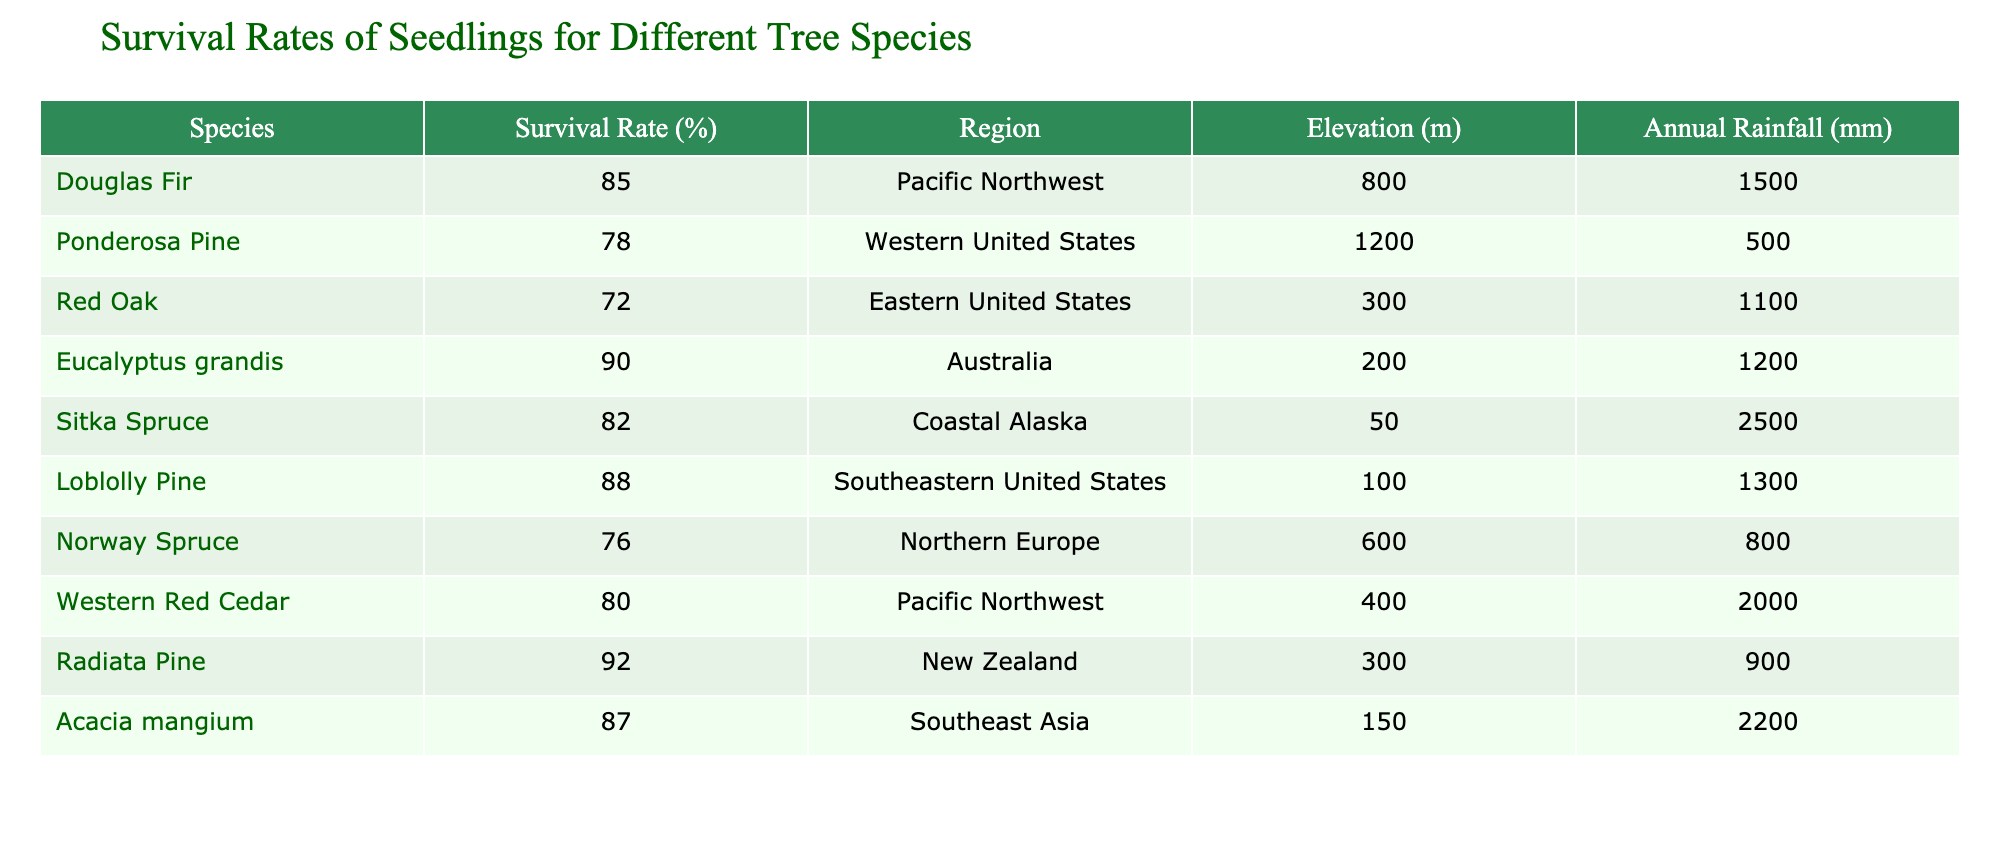What is the survival rate of Eucalyptus grandis? It's listed in the table under the species column and has a corresponding survival rate of 90%.
Answer: 90% Which tree species has the highest survival rate? By looking through the survival rates in the table, Eucalyptus grandis is clearly indicated as having the highest survival rate at 90%.
Answer: Eucalyptus grandis Are Douglas Fir seedlings more likely to survive than Red Oak seedlings? The survival rate for Douglas Fir is 85%, while for Red Oak, it is 72%. Therefore, Douglas Fir seedlings have a higher survival likelihood.
Answer: Yes What is the average survival rate of all tree species listed? We sum the survival rates: 85 + 78 + 72 + 90 + 82 + 88 + 76 + 80 + 92 + 87 = 819. There are 10 species, so we calculate the average as 819 / 10 = 81.9.
Answer: 81.9 Which tree species has the lowest survival rate, and what is that rate? Scanning through the table, Red Oak has the lowest survival rate at 72%.
Answer: Red Oak; 72% Do all species listed show a survival rate above 70%? By reviewing the survival rates, all species recorded have rates of 72% or higher.
Answer: Yes How does the average survival rate of species from Southeast Asia compare to those from the Pacific Northwest? The survival rate for Acacia mangium (87%) is the only one from Southeast Asia. For the Pacific Northwest, Douglas Fir (85%) and Western Red Cedar (80%) average to (85 + 80) / 2 = 82.5. Since 87 > 82.5, Acacia mangium has a higher average.
Answer: Acacia mangium is higher What is the survival rate difference between Radiata Pine and Norway Spruce? The survival rate for Radiata Pine is 92%, while for Norway Spruce it is 76%. The difference is 92 - 76 = 16%.
Answer: 16% Which region has the species with the second highest survival rate? The species with the second highest survival rate is Radiata Pine (92%), and it is from New Zealand.
Answer: New Zealand 